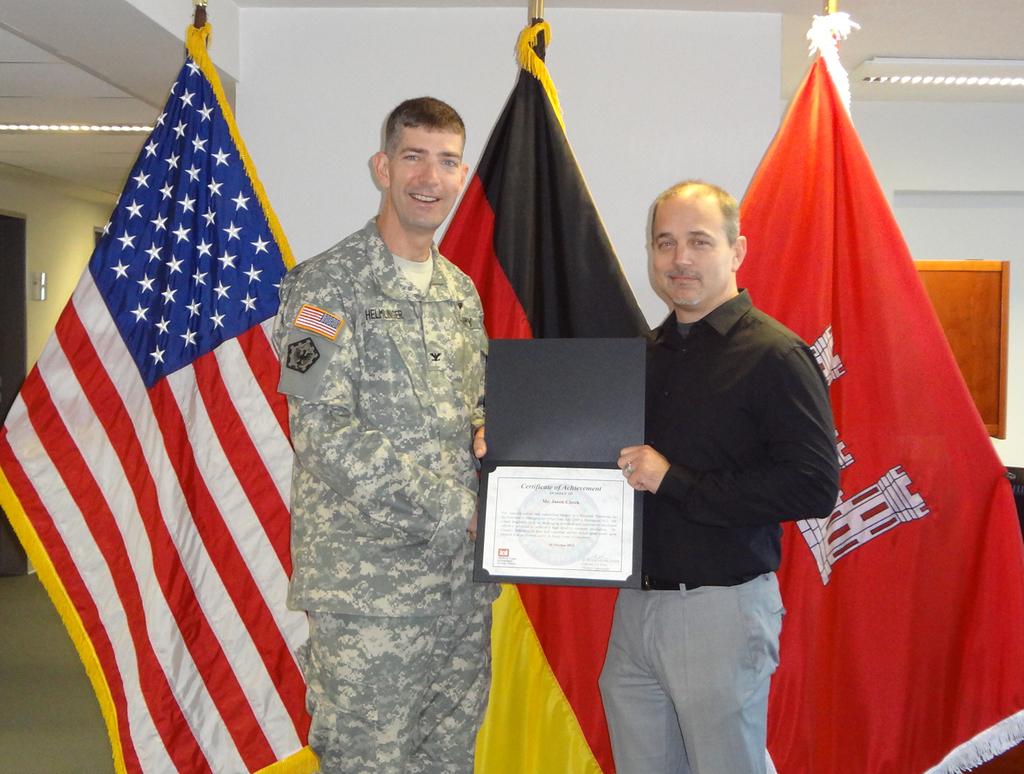What is the soldier's name?
Your response must be concise. Helmunger. 